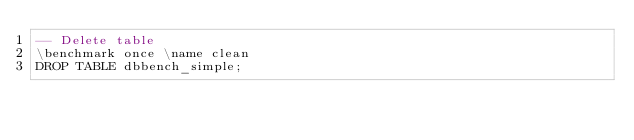Convert code to text. <code><loc_0><loc_0><loc_500><loc_500><_SQL_>-- Delete table
\benchmark once \name clean
DROP TABLE dbbench_simple;</code> 